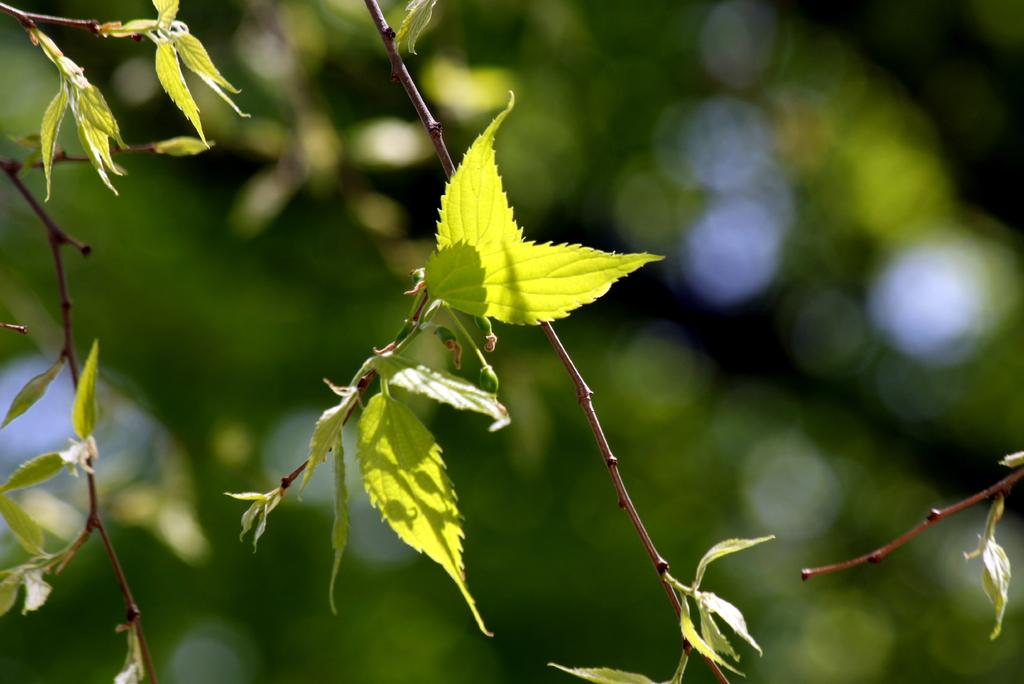What is the main subject of the picture? The main subject of the picture is a plant. What specific features can be observed on the plant? The plant has leaves. Can you describe the background of the image? The backdrop of the image is blurred. What type of match can be seen being lit in the image? There is no match present in the image; it features a plant with leaves and a blurred backdrop. What effect does the cork have on the plant in the image? There is no cork present in the image, so it cannot have any effect on the plant. 